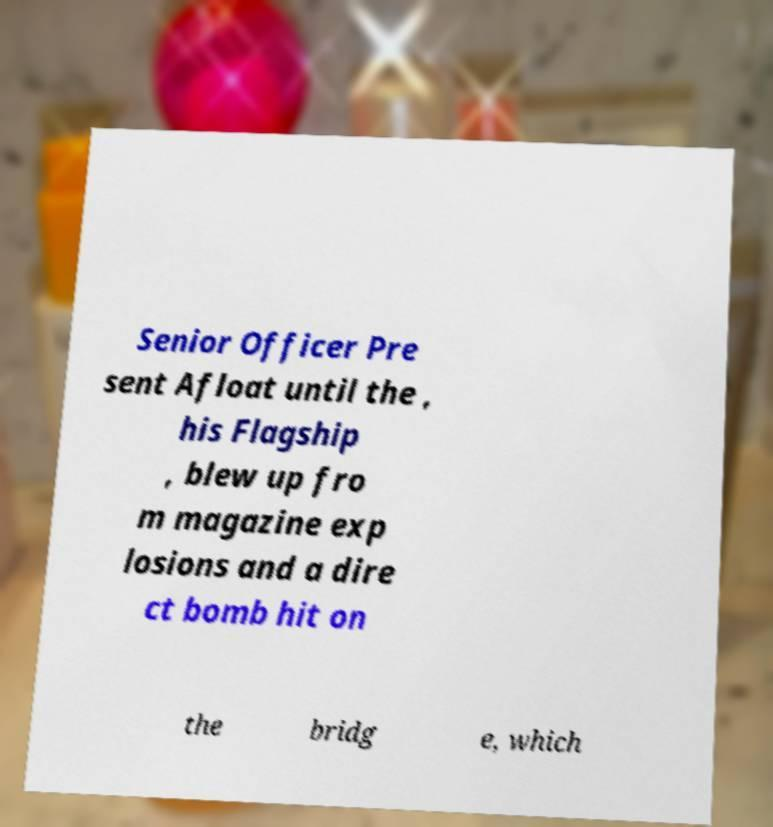Could you assist in decoding the text presented in this image and type it out clearly? Senior Officer Pre sent Afloat until the , his Flagship , blew up fro m magazine exp losions and a dire ct bomb hit on the bridg e, which 